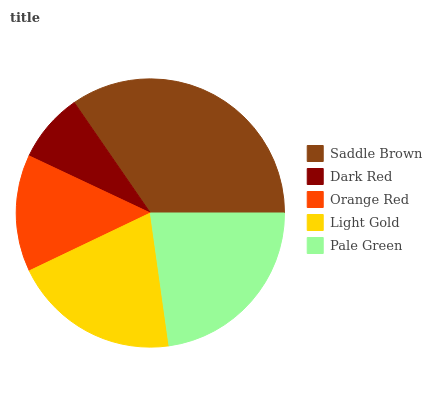Is Dark Red the minimum?
Answer yes or no. Yes. Is Saddle Brown the maximum?
Answer yes or no. Yes. Is Orange Red the minimum?
Answer yes or no. No. Is Orange Red the maximum?
Answer yes or no. No. Is Orange Red greater than Dark Red?
Answer yes or no. Yes. Is Dark Red less than Orange Red?
Answer yes or no. Yes. Is Dark Red greater than Orange Red?
Answer yes or no. No. Is Orange Red less than Dark Red?
Answer yes or no. No. Is Light Gold the high median?
Answer yes or no. Yes. Is Light Gold the low median?
Answer yes or no. Yes. Is Saddle Brown the high median?
Answer yes or no. No. Is Dark Red the low median?
Answer yes or no. No. 